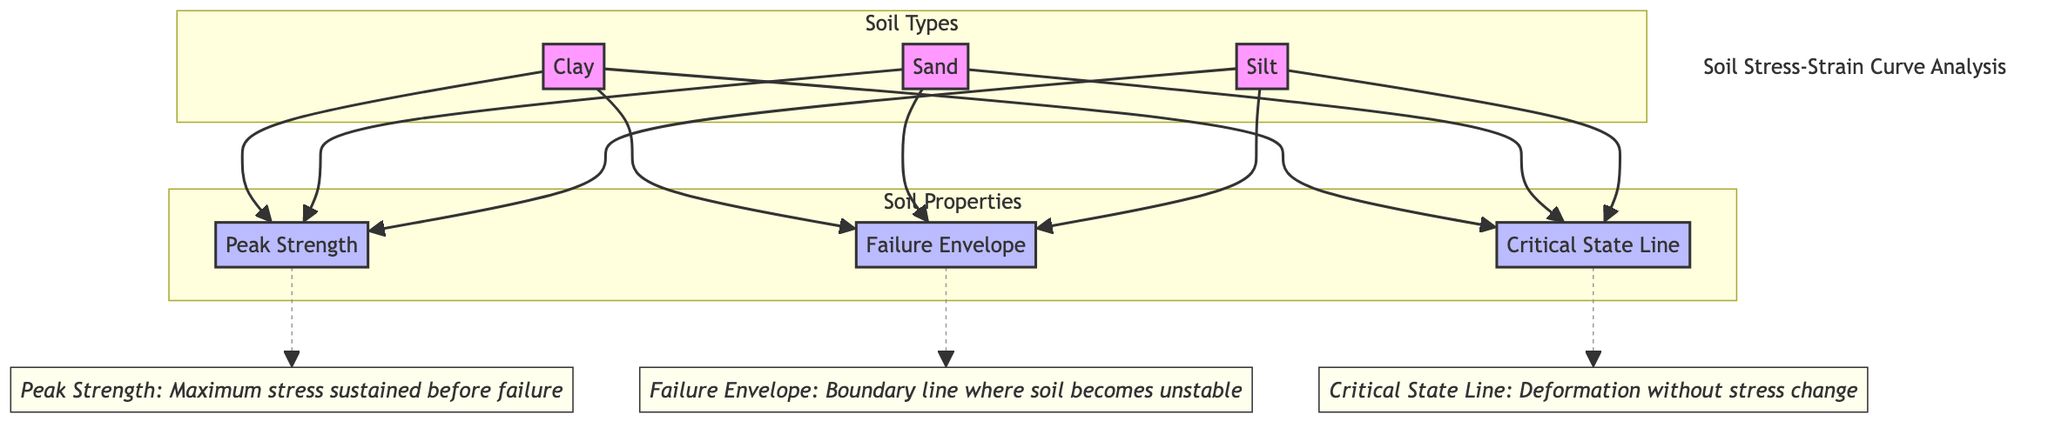What are the soil types illustrated in the diagram? The diagram includes three distinct soil types which are represented as nodes: Clay, Sand, and Silt. By reviewing the labels, we can identify the soil types directly connected to the "Soil Types" subgraph.
Answer: Clay, Sand, Silt How many components are indicated as soil properties? There are three components labeled under "Soil Properties": Peak Strength, Failure Envelope, and Critical State Line. Counting these nodes shows us the total number of distinct soil properties featured in the diagram.
Answer: 3 What does the Peak Strength represent? According to the annotation linked to the Peak Strength node, it signifies the maximum stress sustained by the soil before it fails. The annotation provides a specific definition that explains its significance in soil mechanics.
Answer: Maximum stress What node connects to the Critical State Line? The Critical State Line is connected to all three soil types: Clay, Sand, and Silt. This relationship indicates that each soil type reaches a critical state defined by this line. The connections illustrate the relevance of the Critical State Line for different soil types.
Answer: Clay, Sand, Silt What is the role of the Failure Envelope in the diagram? The Failure Envelope is identified as the boundary line where the soil becomes unstable. The corresponding annotation explicitly states its function, providing clarity about the behavior of soil under stress.
Answer: Boundary line Why is Peak Strength significant for all soil types? Peak Strength is significant for all soil types because it defines the maximum stress that a soil can withstand before failure across different loading conditions. By examining all connections in the diagram, we observe that Peak Strength is a common characteristic for Clay, Sand, and Silt, indicating its universal importance.
Answer: Maximum stress for all types What does the Critical State Line indicate about deformation? The Critical State Line indicates that deformation occurs without a change in stress. This is derived from the specific annotation connected to the Critical State Line, explaining its implication in geotechnical engineering.
Answer: Deformation without stress change How are the Peak Strength and Failure Envelope related? The Peak Strength and Failure Envelope are closely linked, as the Peak Strength represents the maximum stress just before failure, which is quantified by the Failure Envelope. This relationship is visually represented by their direct connection to each soil type, demonstrating the progression from peak strength to failure.
Answer: Peak Strength leads to failure 